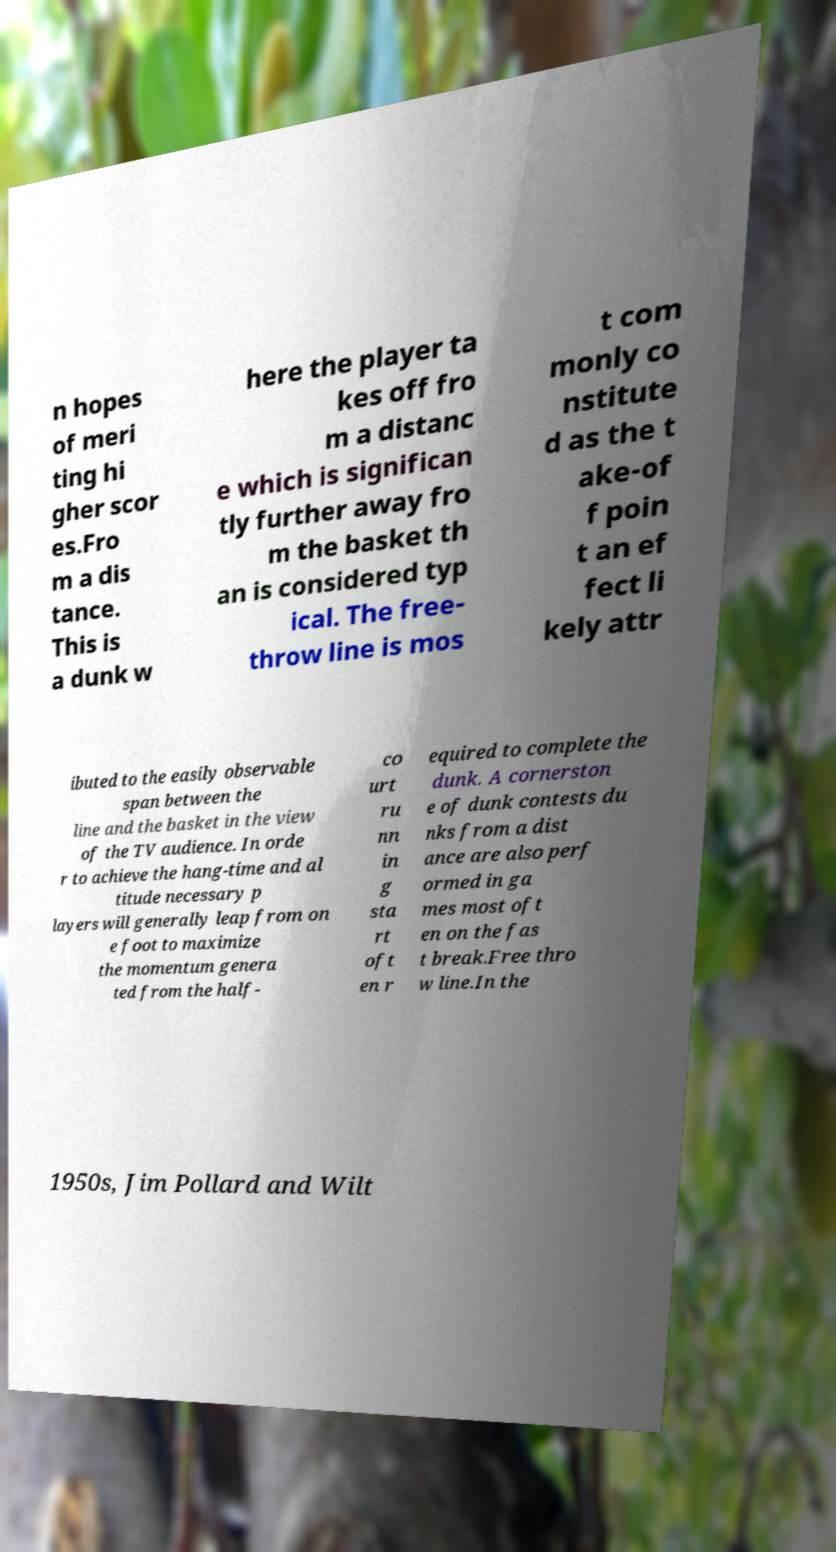There's text embedded in this image that I need extracted. Can you transcribe it verbatim? n hopes of meri ting hi gher scor es.Fro m a dis tance. This is a dunk w here the player ta kes off fro m a distanc e which is significan tly further away fro m the basket th an is considered typ ical. The free- throw line is mos t com monly co nstitute d as the t ake-of f poin t an ef fect li kely attr ibuted to the easily observable span between the line and the basket in the view of the TV audience. In orde r to achieve the hang-time and al titude necessary p layers will generally leap from on e foot to maximize the momentum genera ted from the half- co urt ru nn in g sta rt oft en r equired to complete the dunk. A cornerston e of dunk contests du nks from a dist ance are also perf ormed in ga mes most oft en on the fas t break.Free thro w line.In the 1950s, Jim Pollard and Wilt 